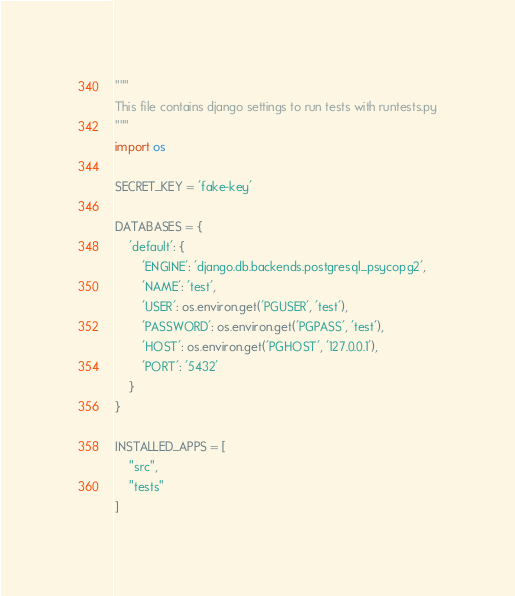Convert code to text. <code><loc_0><loc_0><loc_500><loc_500><_Python_>"""
This file contains django settings to run tests with runtests.py
"""
import os

SECRET_KEY = 'fake-key'

DATABASES = {
    'default': {
        'ENGINE': 'django.db.backends.postgresql_psycopg2',
        'NAME': 'test',
        'USER': os.environ.get('PGUSER', 'test'),
        'PASSWORD': os.environ.get('PGPASS', 'test'),
        'HOST': os.environ.get('PGHOST', '127.0.0.1'),
        'PORT': '5432'
    }
}

INSTALLED_APPS = [
    "src",
    "tests"
]
</code> 